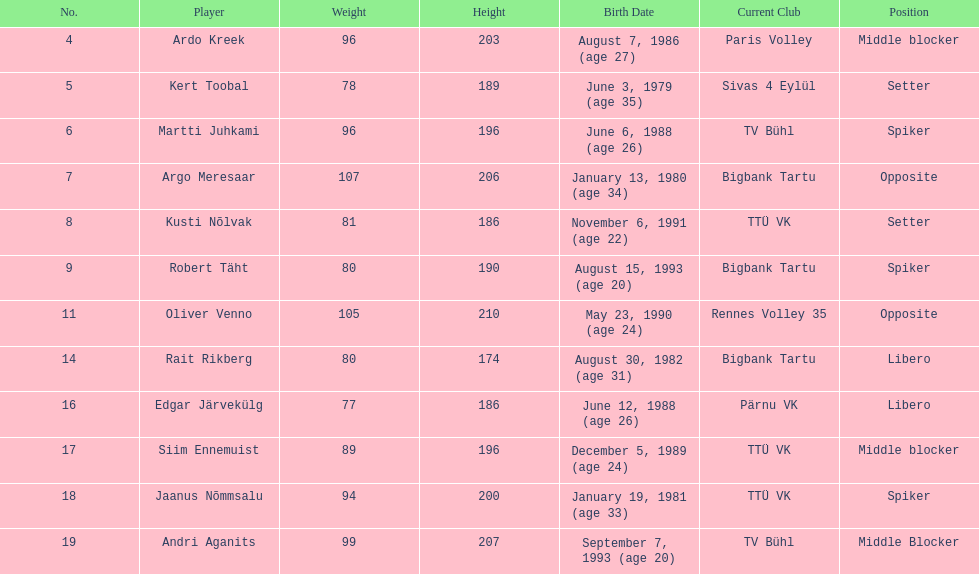How many members of estonia's men's national volleyball team were born in 1988? 2. 